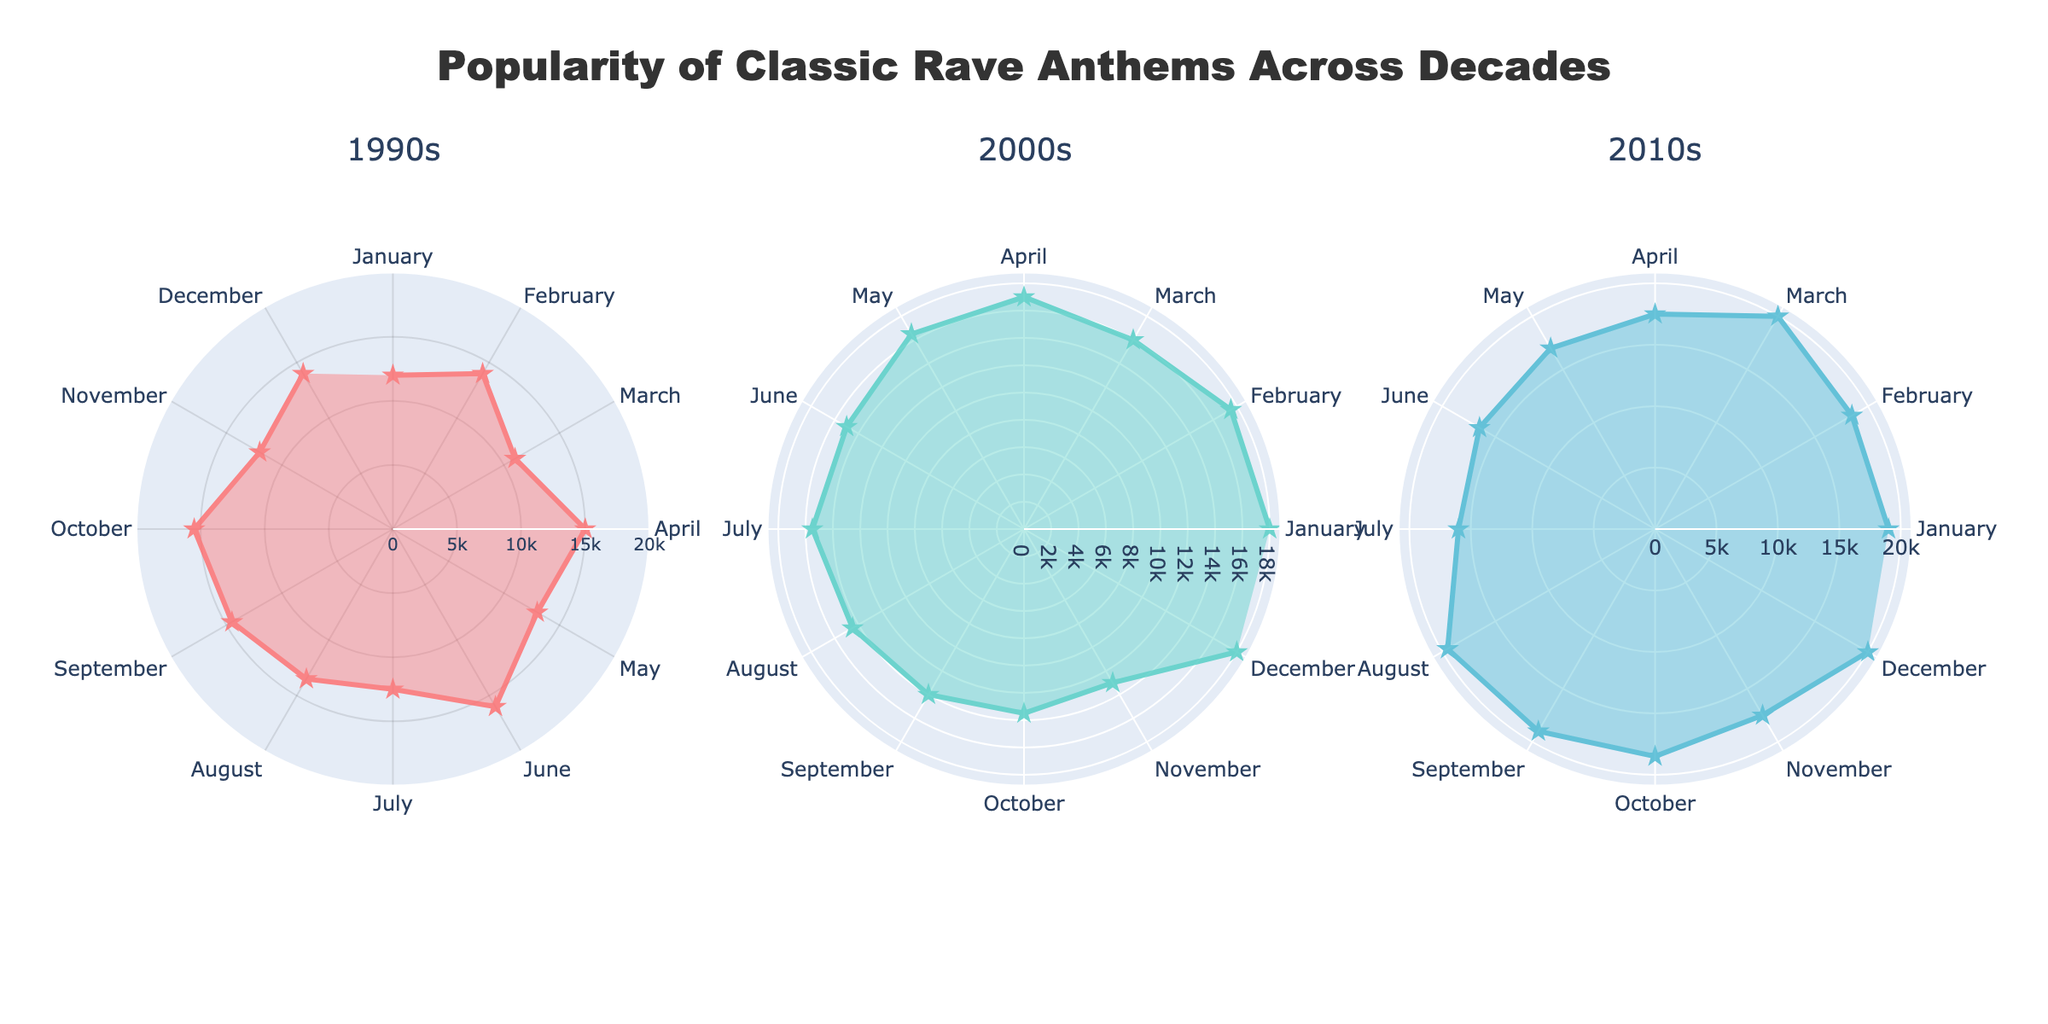What's the title of the figure? The title of the figure is usually found at the top of the plot. Here, it should be clearly indicated.
Answer: Popularity of Classic Rave Anthems Across Decades How many subplots are there in the figure? By counting the distinct charts within the main chart, we see three separate polar charts.
Answer: 3 Which decade has the song with the highest stream count? Looking at the outermost points on the radial axis of each subplot, the 2010s subplot has the furthest point at "Faded" by Alan Walker.
Answer: 2010s In which decade do the streams have the least variation? By eyeballing the spread and range of the radial positions within each subplot, the 2000s have the most consistent stream counts.
Answer: 2000s What song had the highest stream count in the 2000s? The furthest point from the origin in the 2000s subplot indicates the highest stream count, which is "Sandstorm" by Darude.
Answer: Sandstorm by Darude Comparing Blue Monday and Sandstorm, which song received more streams? Looking at the radial positions in their respective subplots, 'Sandstorm' in the 2000s has a higher radial distance than 'Blue Monday' in the 1990s.
Answer: Sandstorm by Darude Which month had the highest aggregate streams across all decades? Add the radial lengths for each month in all subplots. March in the 2010s has the highest single value, but aggregate needs to be calculated.
Answer: December What's the difference in stream counts between the highest points in the 1990s and 2010s? The highest stream counts in the 1990s and 2010s are 16000 and 20000 respectively, so subtracting these gives 4000.
Answer: 4000 Which decade has the song that stands out the most in terms of stream count? The 2010s have "Lean On" by Major Lazer & DJ Snake in March with the highest stream count in the figure, showing a significant standout.
Answer: 2010s 